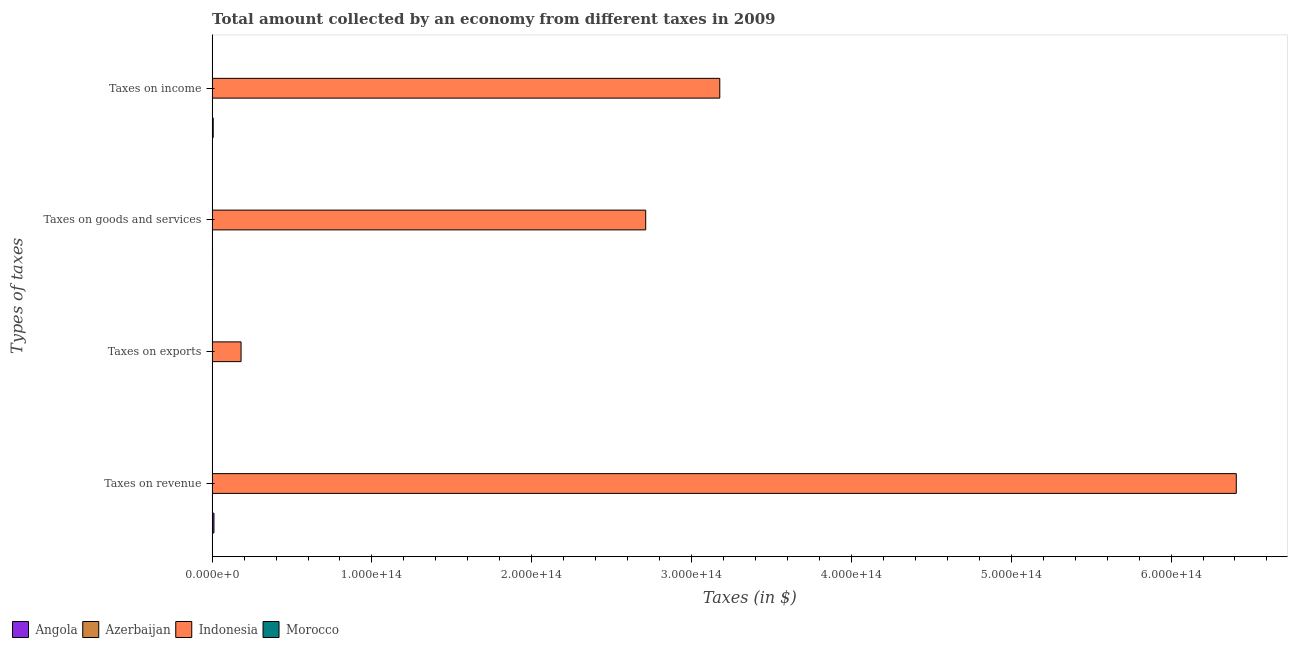How many groups of bars are there?
Provide a short and direct response. 4. Are the number of bars per tick equal to the number of legend labels?
Ensure brevity in your answer.  Yes. What is the label of the 2nd group of bars from the top?
Provide a succinct answer. Taxes on goods and services. What is the amount collected as tax on goods in Indonesia?
Offer a very short reply. 2.71e+14. Across all countries, what is the maximum amount collected as tax on income?
Your response must be concise. 3.18e+14. Across all countries, what is the minimum amount collected as tax on goods?
Keep it short and to the point. 2.59e+09. In which country was the amount collected as tax on goods maximum?
Make the answer very short. Indonesia. In which country was the amount collected as tax on income minimum?
Make the answer very short. Azerbaijan. What is the total amount collected as tax on goods in the graph?
Offer a very short reply. 2.72e+14. What is the difference between the amount collected as tax on goods in Morocco and that in Indonesia?
Your answer should be very brief. -2.71e+14. What is the difference between the amount collected as tax on revenue in Indonesia and the amount collected as tax on income in Azerbaijan?
Provide a succinct answer. 6.41e+14. What is the average amount collected as tax on revenue per country?
Your response must be concise. 1.61e+14. What is the difference between the amount collected as tax on exports and amount collected as tax on income in Morocco?
Provide a short and direct response. -6.75e+1. In how many countries, is the amount collected as tax on income greater than 520000000000000 $?
Your response must be concise. 0. What is the ratio of the amount collected as tax on goods in Angola to that in Indonesia?
Keep it short and to the point. 0. Is the amount collected as tax on exports in Indonesia less than that in Azerbaijan?
Your answer should be very brief. No. What is the difference between the highest and the second highest amount collected as tax on revenue?
Give a very brief answer. 6.40e+14. What is the difference between the highest and the lowest amount collected as tax on exports?
Your answer should be very brief. 1.81e+13. What does the 3rd bar from the top in Taxes on income represents?
Provide a succinct answer. Azerbaijan. Is it the case that in every country, the sum of the amount collected as tax on revenue and amount collected as tax on exports is greater than the amount collected as tax on goods?
Ensure brevity in your answer.  Yes. How many bars are there?
Give a very brief answer. 16. How many countries are there in the graph?
Your answer should be very brief. 4. What is the difference between two consecutive major ticks on the X-axis?
Ensure brevity in your answer.  1.00e+14. Are the values on the major ticks of X-axis written in scientific E-notation?
Keep it short and to the point. Yes. Does the graph contain any zero values?
Offer a terse response. No. Does the graph contain grids?
Give a very brief answer. No. Where does the legend appear in the graph?
Your answer should be compact. Bottom left. How many legend labels are there?
Make the answer very short. 4. What is the title of the graph?
Your response must be concise. Total amount collected by an economy from different taxes in 2009. Does "Turks and Caicos Islands" appear as one of the legend labels in the graph?
Ensure brevity in your answer.  No. What is the label or title of the X-axis?
Provide a short and direct response. Taxes (in $). What is the label or title of the Y-axis?
Provide a short and direct response. Types of taxes. What is the Taxes (in $) in Angola in Taxes on revenue?
Keep it short and to the point. 1.15e+12. What is the Taxes (in $) in Azerbaijan in Taxes on revenue?
Your response must be concise. 5.02e+09. What is the Taxes (in $) in Indonesia in Taxes on revenue?
Ensure brevity in your answer.  6.41e+14. What is the Taxes (in $) in Morocco in Taxes on revenue?
Ensure brevity in your answer.  1.76e+11. What is the Taxes (in $) in Angola in Taxes on exports?
Give a very brief answer. 7.26e+06. What is the Taxes (in $) of Indonesia in Taxes on exports?
Provide a succinct answer. 1.81e+13. What is the Taxes (in $) of Morocco in Taxes on exports?
Offer a very short reply. 2.46e+09. What is the Taxes (in $) in Angola in Taxes on goods and services?
Keep it short and to the point. 2.53e+11. What is the Taxes (in $) in Azerbaijan in Taxes on goods and services?
Your response must be concise. 2.59e+09. What is the Taxes (in $) in Indonesia in Taxes on goods and services?
Offer a terse response. 2.71e+14. What is the Taxes (in $) of Morocco in Taxes on goods and services?
Ensure brevity in your answer.  7.74e+1. What is the Taxes (in $) of Angola in Taxes on income?
Make the answer very short. 6.80e+11. What is the Taxes (in $) in Azerbaijan in Taxes on income?
Your response must be concise. 1.92e+09. What is the Taxes (in $) in Indonesia in Taxes on income?
Keep it short and to the point. 3.18e+14. What is the Taxes (in $) of Morocco in Taxes on income?
Keep it short and to the point. 7.00e+1. Across all Types of taxes, what is the maximum Taxes (in $) in Angola?
Keep it short and to the point. 1.15e+12. Across all Types of taxes, what is the maximum Taxes (in $) of Azerbaijan?
Your answer should be compact. 5.02e+09. Across all Types of taxes, what is the maximum Taxes (in $) of Indonesia?
Offer a terse response. 6.41e+14. Across all Types of taxes, what is the maximum Taxes (in $) in Morocco?
Offer a terse response. 1.76e+11. Across all Types of taxes, what is the minimum Taxes (in $) in Angola?
Give a very brief answer. 7.26e+06. Across all Types of taxes, what is the minimum Taxes (in $) in Indonesia?
Provide a short and direct response. 1.81e+13. Across all Types of taxes, what is the minimum Taxes (in $) in Morocco?
Provide a succinct answer. 2.46e+09. What is the total Taxes (in $) in Angola in the graph?
Offer a terse response. 2.08e+12. What is the total Taxes (in $) in Azerbaijan in the graph?
Make the answer very short. 9.54e+09. What is the total Taxes (in $) in Indonesia in the graph?
Provide a succinct answer. 1.25e+15. What is the total Taxes (in $) in Morocco in the graph?
Provide a short and direct response. 3.25e+11. What is the difference between the Taxes (in $) in Angola in Taxes on revenue and that in Taxes on exports?
Your response must be concise. 1.15e+12. What is the difference between the Taxes (in $) of Azerbaijan in Taxes on revenue and that in Taxes on exports?
Ensure brevity in your answer.  5.02e+09. What is the difference between the Taxes (in $) in Indonesia in Taxes on revenue and that in Taxes on exports?
Offer a very short reply. 6.23e+14. What is the difference between the Taxes (in $) in Morocco in Taxes on revenue and that in Taxes on exports?
Ensure brevity in your answer.  1.73e+11. What is the difference between the Taxes (in $) of Angola in Taxes on revenue and that in Taxes on goods and services?
Offer a very short reply. 8.94e+11. What is the difference between the Taxes (in $) in Azerbaijan in Taxes on revenue and that in Taxes on goods and services?
Ensure brevity in your answer.  2.43e+09. What is the difference between the Taxes (in $) in Indonesia in Taxes on revenue and that in Taxes on goods and services?
Ensure brevity in your answer.  3.70e+14. What is the difference between the Taxes (in $) of Morocco in Taxes on revenue and that in Taxes on goods and services?
Your response must be concise. 9.81e+1. What is the difference between the Taxes (in $) in Angola in Taxes on revenue and that in Taxes on income?
Your answer should be very brief. 4.68e+11. What is the difference between the Taxes (in $) in Azerbaijan in Taxes on revenue and that in Taxes on income?
Offer a very short reply. 3.10e+09. What is the difference between the Taxes (in $) of Indonesia in Taxes on revenue and that in Taxes on income?
Your answer should be very brief. 3.23e+14. What is the difference between the Taxes (in $) in Morocco in Taxes on revenue and that in Taxes on income?
Make the answer very short. 1.06e+11. What is the difference between the Taxes (in $) of Angola in Taxes on exports and that in Taxes on goods and services?
Your answer should be very brief. -2.53e+11. What is the difference between the Taxes (in $) in Azerbaijan in Taxes on exports and that in Taxes on goods and services?
Ensure brevity in your answer.  -2.59e+09. What is the difference between the Taxes (in $) in Indonesia in Taxes on exports and that in Taxes on goods and services?
Make the answer very short. -2.53e+14. What is the difference between the Taxes (in $) in Morocco in Taxes on exports and that in Taxes on goods and services?
Make the answer very short. -7.50e+1. What is the difference between the Taxes (in $) in Angola in Taxes on exports and that in Taxes on income?
Provide a short and direct response. -6.80e+11. What is the difference between the Taxes (in $) of Azerbaijan in Taxes on exports and that in Taxes on income?
Your response must be concise. -1.92e+09. What is the difference between the Taxes (in $) in Indonesia in Taxes on exports and that in Taxes on income?
Provide a succinct answer. -3.00e+14. What is the difference between the Taxes (in $) of Morocco in Taxes on exports and that in Taxes on income?
Your answer should be very brief. -6.75e+1. What is the difference between the Taxes (in $) in Angola in Taxes on goods and services and that in Taxes on income?
Give a very brief answer. -4.26e+11. What is the difference between the Taxes (in $) in Azerbaijan in Taxes on goods and services and that in Taxes on income?
Give a very brief answer. 6.72e+08. What is the difference between the Taxes (in $) of Indonesia in Taxes on goods and services and that in Taxes on income?
Make the answer very short. -4.64e+13. What is the difference between the Taxes (in $) of Morocco in Taxes on goods and services and that in Taxes on income?
Offer a terse response. 7.45e+09. What is the difference between the Taxes (in $) in Angola in Taxes on revenue and the Taxes (in $) in Azerbaijan in Taxes on exports?
Your response must be concise. 1.15e+12. What is the difference between the Taxes (in $) in Angola in Taxes on revenue and the Taxes (in $) in Indonesia in Taxes on exports?
Provide a short and direct response. -1.70e+13. What is the difference between the Taxes (in $) of Angola in Taxes on revenue and the Taxes (in $) of Morocco in Taxes on exports?
Keep it short and to the point. 1.15e+12. What is the difference between the Taxes (in $) of Azerbaijan in Taxes on revenue and the Taxes (in $) of Indonesia in Taxes on exports?
Make the answer very short. -1.81e+13. What is the difference between the Taxes (in $) of Azerbaijan in Taxes on revenue and the Taxes (in $) of Morocco in Taxes on exports?
Make the answer very short. 2.57e+09. What is the difference between the Taxes (in $) in Indonesia in Taxes on revenue and the Taxes (in $) in Morocco in Taxes on exports?
Offer a terse response. 6.41e+14. What is the difference between the Taxes (in $) in Angola in Taxes on revenue and the Taxes (in $) in Azerbaijan in Taxes on goods and services?
Ensure brevity in your answer.  1.15e+12. What is the difference between the Taxes (in $) of Angola in Taxes on revenue and the Taxes (in $) of Indonesia in Taxes on goods and services?
Your response must be concise. -2.70e+14. What is the difference between the Taxes (in $) of Angola in Taxes on revenue and the Taxes (in $) of Morocco in Taxes on goods and services?
Your answer should be compact. 1.07e+12. What is the difference between the Taxes (in $) in Azerbaijan in Taxes on revenue and the Taxes (in $) in Indonesia in Taxes on goods and services?
Provide a short and direct response. -2.71e+14. What is the difference between the Taxes (in $) in Azerbaijan in Taxes on revenue and the Taxes (in $) in Morocco in Taxes on goods and services?
Ensure brevity in your answer.  -7.24e+1. What is the difference between the Taxes (in $) of Indonesia in Taxes on revenue and the Taxes (in $) of Morocco in Taxes on goods and services?
Provide a succinct answer. 6.41e+14. What is the difference between the Taxes (in $) in Angola in Taxes on revenue and the Taxes (in $) in Azerbaijan in Taxes on income?
Your response must be concise. 1.15e+12. What is the difference between the Taxes (in $) of Angola in Taxes on revenue and the Taxes (in $) of Indonesia in Taxes on income?
Provide a succinct answer. -3.17e+14. What is the difference between the Taxes (in $) in Angola in Taxes on revenue and the Taxes (in $) in Morocco in Taxes on income?
Your answer should be very brief. 1.08e+12. What is the difference between the Taxes (in $) in Azerbaijan in Taxes on revenue and the Taxes (in $) in Indonesia in Taxes on income?
Ensure brevity in your answer.  -3.18e+14. What is the difference between the Taxes (in $) in Azerbaijan in Taxes on revenue and the Taxes (in $) in Morocco in Taxes on income?
Keep it short and to the point. -6.50e+1. What is the difference between the Taxes (in $) in Indonesia in Taxes on revenue and the Taxes (in $) in Morocco in Taxes on income?
Your answer should be very brief. 6.41e+14. What is the difference between the Taxes (in $) of Angola in Taxes on exports and the Taxes (in $) of Azerbaijan in Taxes on goods and services?
Provide a short and direct response. -2.59e+09. What is the difference between the Taxes (in $) in Angola in Taxes on exports and the Taxes (in $) in Indonesia in Taxes on goods and services?
Your response must be concise. -2.71e+14. What is the difference between the Taxes (in $) in Angola in Taxes on exports and the Taxes (in $) in Morocco in Taxes on goods and services?
Your answer should be very brief. -7.74e+1. What is the difference between the Taxes (in $) of Azerbaijan in Taxes on exports and the Taxes (in $) of Indonesia in Taxes on goods and services?
Keep it short and to the point. -2.71e+14. What is the difference between the Taxes (in $) of Azerbaijan in Taxes on exports and the Taxes (in $) of Morocco in Taxes on goods and services?
Ensure brevity in your answer.  -7.74e+1. What is the difference between the Taxes (in $) of Indonesia in Taxes on exports and the Taxes (in $) of Morocco in Taxes on goods and services?
Provide a succinct answer. 1.80e+13. What is the difference between the Taxes (in $) in Angola in Taxes on exports and the Taxes (in $) in Azerbaijan in Taxes on income?
Give a very brief answer. -1.91e+09. What is the difference between the Taxes (in $) of Angola in Taxes on exports and the Taxes (in $) of Indonesia in Taxes on income?
Your answer should be compact. -3.18e+14. What is the difference between the Taxes (in $) of Angola in Taxes on exports and the Taxes (in $) of Morocco in Taxes on income?
Provide a succinct answer. -7.00e+1. What is the difference between the Taxes (in $) in Azerbaijan in Taxes on exports and the Taxes (in $) in Indonesia in Taxes on income?
Your answer should be compact. -3.18e+14. What is the difference between the Taxes (in $) in Azerbaijan in Taxes on exports and the Taxes (in $) in Morocco in Taxes on income?
Provide a short and direct response. -7.00e+1. What is the difference between the Taxes (in $) in Indonesia in Taxes on exports and the Taxes (in $) in Morocco in Taxes on income?
Your answer should be compact. 1.80e+13. What is the difference between the Taxes (in $) in Angola in Taxes on goods and services and the Taxes (in $) in Azerbaijan in Taxes on income?
Your answer should be very brief. 2.52e+11. What is the difference between the Taxes (in $) in Angola in Taxes on goods and services and the Taxes (in $) in Indonesia in Taxes on income?
Keep it short and to the point. -3.17e+14. What is the difference between the Taxes (in $) in Angola in Taxes on goods and services and the Taxes (in $) in Morocco in Taxes on income?
Keep it short and to the point. 1.84e+11. What is the difference between the Taxes (in $) of Azerbaijan in Taxes on goods and services and the Taxes (in $) of Indonesia in Taxes on income?
Offer a very short reply. -3.18e+14. What is the difference between the Taxes (in $) of Azerbaijan in Taxes on goods and services and the Taxes (in $) of Morocco in Taxes on income?
Make the answer very short. -6.74e+1. What is the difference between the Taxes (in $) in Indonesia in Taxes on goods and services and the Taxes (in $) in Morocco in Taxes on income?
Your response must be concise. 2.71e+14. What is the average Taxes (in $) in Angola per Types of taxes?
Make the answer very short. 5.20e+11. What is the average Taxes (in $) of Azerbaijan per Types of taxes?
Your answer should be compact. 2.38e+09. What is the average Taxes (in $) of Indonesia per Types of taxes?
Keep it short and to the point. 3.12e+14. What is the average Taxes (in $) of Morocco per Types of taxes?
Offer a terse response. 8.14e+1. What is the difference between the Taxes (in $) of Angola and Taxes (in $) of Azerbaijan in Taxes on revenue?
Provide a short and direct response. 1.14e+12. What is the difference between the Taxes (in $) in Angola and Taxes (in $) in Indonesia in Taxes on revenue?
Your answer should be very brief. -6.40e+14. What is the difference between the Taxes (in $) in Angola and Taxes (in $) in Morocco in Taxes on revenue?
Offer a terse response. 9.72e+11. What is the difference between the Taxes (in $) in Azerbaijan and Taxes (in $) in Indonesia in Taxes on revenue?
Offer a terse response. -6.41e+14. What is the difference between the Taxes (in $) in Azerbaijan and Taxes (in $) in Morocco in Taxes on revenue?
Provide a succinct answer. -1.71e+11. What is the difference between the Taxes (in $) of Indonesia and Taxes (in $) of Morocco in Taxes on revenue?
Your answer should be very brief. 6.41e+14. What is the difference between the Taxes (in $) in Angola and Taxes (in $) in Azerbaijan in Taxes on exports?
Give a very brief answer. 7.06e+06. What is the difference between the Taxes (in $) in Angola and Taxes (in $) in Indonesia in Taxes on exports?
Your answer should be very brief. -1.81e+13. What is the difference between the Taxes (in $) in Angola and Taxes (in $) in Morocco in Taxes on exports?
Keep it short and to the point. -2.45e+09. What is the difference between the Taxes (in $) of Azerbaijan and Taxes (in $) of Indonesia in Taxes on exports?
Ensure brevity in your answer.  -1.81e+13. What is the difference between the Taxes (in $) in Azerbaijan and Taxes (in $) in Morocco in Taxes on exports?
Your answer should be compact. -2.46e+09. What is the difference between the Taxes (in $) in Indonesia and Taxes (in $) in Morocco in Taxes on exports?
Your answer should be very brief. 1.81e+13. What is the difference between the Taxes (in $) of Angola and Taxes (in $) of Azerbaijan in Taxes on goods and services?
Your response must be concise. 2.51e+11. What is the difference between the Taxes (in $) in Angola and Taxes (in $) in Indonesia in Taxes on goods and services?
Your answer should be compact. -2.71e+14. What is the difference between the Taxes (in $) in Angola and Taxes (in $) in Morocco in Taxes on goods and services?
Your answer should be compact. 1.76e+11. What is the difference between the Taxes (in $) of Azerbaijan and Taxes (in $) of Indonesia in Taxes on goods and services?
Provide a short and direct response. -2.71e+14. What is the difference between the Taxes (in $) in Azerbaijan and Taxes (in $) in Morocco in Taxes on goods and services?
Keep it short and to the point. -7.49e+1. What is the difference between the Taxes (in $) in Indonesia and Taxes (in $) in Morocco in Taxes on goods and services?
Your answer should be very brief. 2.71e+14. What is the difference between the Taxes (in $) of Angola and Taxes (in $) of Azerbaijan in Taxes on income?
Make the answer very short. 6.78e+11. What is the difference between the Taxes (in $) in Angola and Taxes (in $) in Indonesia in Taxes on income?
Your answer should be compact. -3.17e+14. What is the difference between the Taxes (in $) of Angola and Taxes (in $) of Morocco in Taxes on income?
Ensure brevity in your answer.  6.10e+11. What is the difference between the Taxes (in $) of Azerbaijan and Taxes (in $) of Indonesia in Taxes on income?
Your answer should be compact. -3.18e+14. What is the difference between the Taxes (in $) of Azerbaijan and Taxes (in $) of Morocco in Taxes on income?
Ensure brevity in your answer.  -6.81e+1. What is the difference between the Taxes (in $) in Indonesia and Taxes (in $) in Morocco in Taxes on income?
Provide a short and direct response. 3.18e+14. What is the ratio of the Taxes (in $) in Angola in Taxes on revenue to that in Taxes on exports?
Make the answer very short. 1.58e+05. What is the ratio of the Taxes (in $) in Azerbaijan in Taxes on revenue to that in Taxes on exports?
Provide a succinct answer. 2.51e+04. What is the ratio of the Taxes (in $) in Indonesia in Taxes on revenue to that in Taxes on exports?
Ensure brevity in your answer.  35.39. What is the ratio of the Taxes (in $) in Morocco in Taxes on revenue to that in Taxes on exports?
Provide a short and direct response. 71.48. What is the ratio of the Taxes (in $) of Angola in Taxes on revenue to that in Taxes on goods and services?
Make the answer very short. 4.53. What is the ratio of the Taxes (in $) of Azerbaijan in Taxes on revenue to that in Taxes on goods and services?
Provide a succinct answer. 1.94. What is the ratio of the Taxes (in $) in Indonesia in Taxes on revenue to that in Taxes on goods and services?
Ensure brevity in your answer.  2.36. What is the ratio of the Taxes (in $) in Morocco in Taxes on revenue to that in Taxes on goods and services?
Your answer should be compact. 2.27. What is the ratio of the Taxes (in $) of Angola in Taxes on revenue to that in Taxes on income?
Keep it short and to the point. 1.69. What is the ratio of the Taxes (in $) of Azerbaijan in Taxes on revenue to that in Taxes on income?
Your answer should be compact. 2.62. What is the ratio of the Taxes (in $) of Indonesia in Taxes on revenue to that in Taxes on income?
Offer a terse response. 2.02. What is the ratio of the Taxes (in $) of Morocco in Taxes on revenue to that in Taxes on income?
Your answer should be very brief. 2.51. What is the ratio of the Taxes (in $) of Indonesia in Taxes on exports to that in Taxes on goods and services?
Your answer should be compact. 0.07. What is the ratio of the Taxes (in $) in Morocco in Taxes on exports to that in Taxes on goods and services?
Give a very brief answer. 0.03. What is the ratio of the Taxes (in $) of Angola in Taxes on exports to that in Taxes on income?
Your answer should be very brief. 0. What is the ratio of the Taxes (in $) in Azerbaijan in Taxes on exports to that in Taxes on income?
Ensure brevity in your answer.  0. What is the ratio of the Taxes (in $) in Indonesia in Taxes on exports to that in Taxes on income?
Make the answer very short. 0.06. What is the ratio of the Taxes (in $) in Morocco in Taxes on exports to that in Taxes on income?
Ensure brevity in your answer.  0.04. What is the ratio of the Taxes (in $) of Angola in Taxes on goods and services to that in Taxes on income?
Ensure brevity in your answer.  0.37. What is the ratio of the Taxes (in $) in Azerbaijan in Taxes on goods and services to that in Taxes on income?
Your answer should be compact. 1.35. What is the ratio of the Taxes (in $) of Indonesia in Taxes on goods and services to that in Taxes on income?
Provide a short and direct response. 0.85. What is the ratio of the Taxes (in $) in Morocco in Taxes on goods and services to that in Taxes on income?
Give a very brief answer. 1.11. What is the difference between the highest and the second highest Taxes (in $) of Angola?
Make the answer very short. 4.68e+11. What is the difference between the highest and the second highest Taxes (in $) of Azerbaijan?
Your answer should be compact. 2.43e+09. What is the difference between the highest and the second highest Taxes (in $) of Indonesia?
Provide a succinct answer. 3.23e+14. What is the difference between the highest and the second highest Taxes (in $) in Morocco?
Keep it short and to the point. 9.81e+1. What is the difference between the highest and the lowest Taxes (in $) in Angola?
Provide a short and direct response. 1.15e+12. What is the difference between the highest and the lowest Taxes (in $) in Azerbaijan?
Offer a very short reply. 5.02e+09. What is the difference between the highest and the lowest Taxes (in $) of Indonesia?
Provide a succinct answer. 6.23e+14. What is the difference between the highest and the lowest Taxes (in $) of Morocco?
Give a very brief answer. 1.73e+11. 